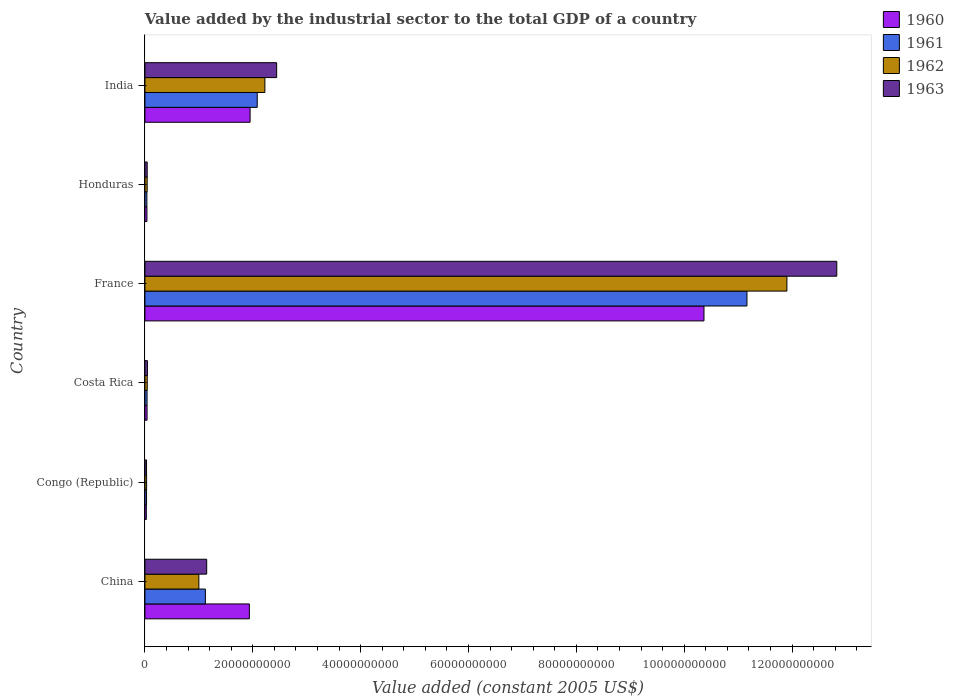How many groups of bars are there?
Make the answer very short. 6. Are the number of bars on each tick of the Y-axis equal?
Your response must be concise. Yes. What is the label of the 1st group of bars from the top?
Ensure brevity in your answer.  India. What is the value added by the industrial sector in 1961 in Honduras?
Ensure brevity in your answer.  3.66e+08. Across all countries, what is the maximum value added by the industrial sector in 1963?
Your answer should be compact. 1.28e+11. Across all countries, what is the minimum value added by the industrial sector in 1961?
Your response must be concise. 2.98e+08. In which country was the value added by the industrial sector in 1961 maximum?
Your response must be concise. France. In which country was the value added by the industrial sector in 1963 minimum?
Provide a succinct answer. Congo (Republic). What is the total value added by the industrial sector in 1962 in the graph?
Ensure brevity in your answer.  1.52e+11. What is the difference between the value added by the industrial sector in 1963 in Congo (Republic) and that in France?
Offer a terse response. -1.28e+11. What is the difference between the value added by the industrial sector in 1960 in Congo (Republic) and the value added by the industrial sector in 1962 in China?
Offer a very short reply. -9.74e+09. What is the average value added by the industrial sector in 1963 per country?
Make the answer very short. 2.76e+1. What is the difference between the value added by the industrial sector in 1960 and value added by the industrial sector in 1961 in Congo (Republic)?
Provide a short and direct response. -3.63e+07. What is the ratio of the value added by the industrial sector in 1960 in Congo (Republic) to that in Honduras?
Your response must be concise. 0.7. Is the value added by the industrial sector in 1962 in China less than that in France?
Offer a terse response. Yes. Is the difference between the value added by the industrial sector in 1960 in Costa Rica and France greater than the difference between the value added by the industrial sector in 1961 in Costa Rica and France?
Give a very brief answer. Yes. What is the difference between the highest and the second highest value added by the industrial sector in 1961?
Provide a succinct answer. 9.08e+1. What is the difference between the highest and the lowest value added by the industrial sector in 1961?
Give a very brief answer. 1.11e+11. In how many countries, is the value added by the industrial sector in 1962 greater than the average value added by the industrial sector in 1962 taken over all countries?
Make the answer very short. 1. Is the sum of the value added by the industrial sector in 1962 in Congo (Republic) and Costa Rica greater than the maximum value added by the industrial sector in 1960 across all countries?
Ensure brevity in your answer.  No. Is it the case that in every country, the sum of the value added by the industrial sector in 1962 and value added by the industrial sector in 1963 is greater than the sum of value added by the industrial sector in 1960 and value added by the industrial sector in 1961?
Offer a terse response. No. What does the 4th bar from the top in China represents?
Offer a very short reply. 1960. Are all the bars in the graph horizontal?
Your answer should be very brief. Yes. What is the difference between two consecutive major ticks on the X-axis?
Your response must be concise. 2.00e+1. Are the values on the major ticks of X-axis written in scientific E-notation?
Keep it short and to the point. No. Does the graph contain grids?
Ensure brevity in your answer.  No. Where does the legend appear in the graph?
Make the answer very short. Top right. What is the title of the graph?
Your answer should be compact. Value added by the industrial sector to the total GDP of a country. What is the label or title of the X-axis?
Offer a very short reply. Value added (constant 2005 US$). What is the Value added (constant 2005 US$) in 1960 in China?
Your answer should be very brief. 1.94e+1. What is the Value added (constant 2005 US$) in 1961 in China?
Keep it short and to the point. 1.12e+1. What is the Value added (constant 2005 US$) in 1962 in China?
Offer a very short reply. 1.00e+1. What is the Value added (constant 2005 US$) in 1963 in China?
Offer a very short reply. 1.15e+1. What is the Value added (constant 2005 US$) of 1960 in Congo (Republic)?
Offer a terse response. 2.61e+08. What is the Value added (constant 2005 US$) in 1961 in Congo (Republic)?
Make the answer very short. 2.98e+08. What is the Value added (constant 2005 US$) of 1962 in Congo (Republic)?
Ensure brevity in your answer.  3.12e+08. What is the Value added (constant 2005 US$) of 1963 in Congo (Republic)?
Give a very brief answer. 3.00e+08. What is the Value added (constant 2005 US$) in 1960 in Costa Rica?
Provide a short and direct response. 3.98e+08. What is the Value added (constant 2005 US$) of 1961 in Costa Rica?
Keep it short and to the point. 3.94e+08. What is the Value added (constant 2005 US$) in 1962 in Costa Rica?
Your answer should be very brief. 4.27e+08. What is the Value added (constant 2005 US$) of 1963 in Costa Rica?
Provide a short and direct response. 4.68e+08. What is the Value added (constant 2005 US$) of 1960 in France?
Your answer should be compact. 1.04e+11. What is the Value added (constant 2005 US$) in 1961 in France?
Provide a short and direct response. 1.12e+11. What is the Value added (constant 2005 US$) of 1962 in France?
Offer a terse response. 1.19e+11. What is the Value added (constant 2005 US$) in 1963 in France?
Offer a very short reply. 1.28e+11. What is the Value added (constant 2005 US$) of 1960 in Honduras?
Ensure brevity in your answer.  3.75e+08. What is the Value added (constant 2005 US$) of 1961 in Honduras?
Offer a very short reply. 3.66e+08. What is the Value added (constant 2005 US$) in 1962 in Honduras?
Your answer should be very brief. 4.16e+08. What is the Value added (constant 2005 US$) of 1963 in Honduras?
Make the answer very short. 4.23e+08. What is the Value added (constant 2005 US$) of 1960 in India?
Offer a very short reply. 1.95e+1. What is the Value added (constant 2005 US$) in 1961 in India?
Make the answer very short. 2.08e+1. What is the Value added (constant 2005 US$) in 1962 in India?
Offer a terse response. 2.22e+1. What is the Value added (constant 2005 US$) in 1963 in India?
Your response must be concise. 2.44e+1. Across all countries, what is the maximum Value added (constant 2005 US$) of 1960?
Your response must be concise. 1.04e+11. Across all countries, what is the maximum Value added (constant 2005 US$) in 1961?
Offer a terse response. 1.12e+11. Across all countries, what is the maximum Value added (constant 2005 US$) of 1962?
Keep it short and to the point. 1.19e+11. Across all countries, what is the maximum Value added (constant 2005 US$) in 1963?
Offer a very short reply. 1.28e+11. Across all countries, what is the minimum Value added (constant 2005 US$) of 1960?
Your response must be concise. 2.61e+08. Across all countries, what is the minimum Value added (constant 2005 US$) of 1961?
Your response must be concise. 2.98e+08. Across all countries, what is the minimum Value added (constant 2005 US$) in 1962?
Provide a short and direct response. 3.12e+08. Across all countries, what is the minimum Value added (constant 2005 US$) of 1963?
Provide a succinct answer. 3.00e+08. What is the total Value added (constant 2005 US$) in 1960 in the graph?
Offer a terse response. 1.44e+11. What is the total Value added (constant 2005 US$) in 1961 in the graph?
Offer a terse response. 1.45e+11. What is the total Value added (constant 2005 US$) of 1962 in the graph?
Provide a short and direct response. 1.52e+11. What is the total Value added (constant 2005 US$) in 1963 in the graph?
Your answer should be very brief. 1.65e+11. What is the difference between the Value added (constant 2005 US$) in 1960 in China and that in Congo (Republic)?
Your answer should be compact. 1.91e+1. What is the difference between the Value added (constant 2005 US$) of 1961 in China and that in Congo (Republic)?
Offer a very short reply. 1.09e+1. What is the difference between the Value added (constant 2005 US$) of 1962 in China and that in Congo (Republic)?
Your answer should be compact. 9.69e+09. What is the difference between the Value added (constant 2005 US$) in 1963 in China and that in Congo (Republic)?
Keep it short and to the point. 1.12e+1. What is the difference between the Value added (constant 2005 US$) in 1960 in China and that in Costa Rica?
Give a very brief answer. 1.90e+1. What is the difference between the Value added (constant 2005 US$) in 1961 in China and that in Costa Rica?
Your response must be concise. 1.08e+1. What is the difference between the Value added (constant 2005 US$) of 1962 in China and that in Costa Rica?
Ensure brevity in your answer.  9.58e+09. What is the difference between the Value added (constant 2005 US$) of 1963 in China and that in Costa Rica?
Give a very brief answer. 1.10e+1. What is the difference between the Value added (constant 2005 US$) in 1960 in China and that in France?
Provide a short and direct response. -8.43e+1. What is the difference between the Value added (constant 2005 US$) in 1961 in China and that in France?
Provide a short and direct response. -1.00e+11. What is the difference between the Value added (constant 2005 US$) in 1962 in China and that in France?
Ensure brevity in your answer.  -1.09e+11. What is the difference between the Value added (constant 2005 US$) in 1963 in China and that in France?
Keep it short and to the point. -1.17e+11. What is the difference between the Value added (constant 2005 US$) of 1960 in China and that in Honduras?
Offer a terse response. 1.90e+1. What is the difference between the Value added (constant 2005 US$) of 1961 in China and that in Honduras?
Your answer should be very brief. 1.08e+1. What is the difference between the Value added (constant 2005 US$) of 1962 in China and that in Honduras?
Provide a succinct answer. 9.59e+09. What is the difference between the Value added (constant 2005 US$) of 1963 in China and that in Honduras?
Offer a terse response. 1.10e+1. What is the difference between the Value added (constant 2005 US$) of 1960 in China and that in India?
Your answer should be very brief. -1.35e+08. What is the difference between the Value added (constant 2005 US$) in 1961 in China and that in India?
Offer a very short reply. -9.61e+09. What is the difference between the Value added (constant 2005 US$) in 1962 in China and that in India?
Offer a terse response. -1.22e+1. What is the difference between the Value added (constant 2005 US$) in 1963 in China and that in India?
Give a very brief answer. -1.30e+1. What is the difference between the Value added (constant 2005 US$) in 1960 in Congo (Republic) and that in Costa Rica?
Ensure brevity in your answer.  -1.36e+08. What is the difference between the Value added (constant 2005 US$) in 1961 in Congo (Republic) and that in Costa Rica?
Give a very brief answer. -9.59e+07. What is the difference between the Value added (constant 2005 US$) of 1962 in Congo (Republic) and that in Costa Rica?
Your answer should be compact. -1.14e+08. What is the difference between the Value added (constant 2005 US$) in 1963 in Congo (Republic) and that in Costa Rica?
Offer a very short reply. -1.68e+08. What is the difference between the Value added (constant 2005 US$) in 1960 in Congo (Republic) and that in France?
Your answer should be very brief. -1.03e+11. What is the difference between the Value added (constant 2005 US$) in 1961 in Congo (Republic) and that in France?
Your answer should be compact. -1.11e+11. What is the difference between the Value added (constant 2005 US$) in 1962 in Congo (Republic) and that in France?
Ensure brevity in your answer.  -1.19e+11. What is the difference between the Value added (constant 2005 US$) of 1963 in Congo (Republic) and that in France?
Provide a succinct answer. -1.28e+11. What is the difference between the Value added (constant 2005 US$) of 1960 in Congo (Republic) and that in Honduras?
Offer a very short reply. -1.14e+08. What is the difference between the Value added (constant 2005 US$) of 1961 in Congo (Republic) and that in Honduras?
Keep it short and to the point. -6.81e+07. What is the difference between the Value added (constant 2005 US$) in 1962 in Congo (Republic) and that in Honduras?
Offer a very short reply. -1.03e+08. What is the difference between the Value added (constant 2005 US$) of 1963 in Congo (Republic) and that in Honduras?
Your response must be concise. -1.23e+08. What is the difference between the Value added (constant 2005 US$) in 1960 in Congo (Republic) and that in India?
Ensure brevity in your answer.  -1.92e+1. What is the difference between the Value added (constant 2005 US$) of 1961 in Congo (Republic) and that in India?
Keep it short and to the point. -2.05e+1. What is the difference between the Value added (constant 2005 US$) in 1962 in Congo (Republic) and that in India?
Provide a short and direct response. -2.19e+1. What is the difference between the Value added (constant 2005 US$) in 1963 in Congo (Republic) and that in India?
Give a very brief answer. -2.41e+1. What is the difference between the Value added (constant 2005 US$) in 1960 in Costa Rica and that in France?
Offer a very short reply. -1.03e+11. What is the difference between the Value added (constant 2005 US$) of 1961 in Costa Rica and that in France?
Ensure brevity in your answer.  -1.11e+11. What is the difference between the Value added (constant 2005 US$) of 1962 in Costa Rica and that in France?
Offer a very short reply. -1.19e+11. What is the difference between the Value added (constant 2005 US$) of 1963 in Costa Rica and that in France?
Offer a very short reply. -1.28e+11. What is the difference between the Value added (constant 2005 US$) of 1960 in Costa Rica and that in Honduras?
Give a very brief answer. 2.26e+07. What is the difference between the Value added (constant 2005 US$) in 1961 in Costa Rica and that in Honduras?
Keep it short and to the point. 2.78e+07. What is the difference between the Value added (constant 2005 US$) of 1962 in Costa Rica and that in Honduras?
Offer a very short reply. 1.10e+07. What is the difference between the Value added (constant 2005 US$) in 1963 in Costa Rica and that in Honduras?
Offer a terse response. 4.49e+07. What is the difference between the Value added (constant 2005 US$) in 1960 in Costa Rica and that in India?
Provide a short and direct response. -1.91e+1. What is the difference between the Value added (constant 2005 US$) of 1961 in Costa Rica and that in India?
Your answer should be very brief. -2.04e+1. What is the difference between the Value added (constant 2005 US$) of 1962 in Costa Rica and that in India?
Keep it short and to the point. -2.18e+1. What is the difference between the Value added (constant 2005 US$) in 1963 in Costa Rica and that in India?
Offer a very short reply. -2.40e+1. What is the difference between the Value added (constant 2005 US$) in 1960 in France and that in Honduras?
Give a very brief answer. 1.03e+11. What is the difference between the Value added (constant 2005 US$) in 1961 in France and that in Honduras?
Your response must be concise. 1.11e+11. What is the difference between the Value added (constant 2005 US$) of 1962 in France and that in Honduras?
Offer a terse response. 1.19e+11. What is the difference between the Value added (constant 2005 US$) in 1963 in France and that in Honduras?
Your answer should be compact. 1.28e+11. What is the difference between the Value added (constant 2005 US$) in 1960 in France and that in India?
Offer a very short reply. 8.42e+1. What is the difference between the Value added (constant 2005 US$) of 1961 in France and that in India?
Give a very brief answer. 9.08e+1. What is the difference between the Value added (constant 2005 US$) in 1962 in France and that in India?
Give a very brief answer. 9.68e+1. What is the difference between the Value added (constant 2005 US$) of 1963 in France and that in India?
Provide a succinct answer. 1.04e+11. What is the difference between the Value added (constant 2005 US$) of 1960 in Honduras and that in India?
Offer a very short reply. -1.91e+1. What is the difference between the Value added (constant 2005 US$) of 1961 in Honduras and that in India?
Make the answer very short. -2.05e+1. What is the difference between the Value added (constant 2005 US$) of 1962 in Honduras and that in India?
Your answer should be very brief. -2.18e+1. What is the difference between the Value added (constant 2005 US$) of 1963 in Honduras and that in India?
Give a very brief answer. -2.40e+1. What is the difference between the Value added (constant 2005 US$) of 1960 in China and the Value added (constant 2005 US$) of 1961 in Congo (Republic)?
Make the answer very short. 1.91e+1. What is the difference between the Value added (constant 2005 US$) of 1960 in China and the Value added (constant 2005 US$) of 1962 in Congo (Republic)?
Provide a short and direct response. 1.91e+1. What is the difference between the Value added (constant 2005 US$) of 1960 in China and the Value added (constant 2005 US$) of 1963 in Congo (Republic)?
Your response must be concise. 1.91e+1. What is the difference between the Value added (constant 2005 US$) in 1961 in China and the Value added (constant 2005 US$) in 1962 in Congo (Republic)?
Provide a succinct answer. 1.09e+1. What is the difference between the Value added (constant 2005 US$) of 1961 in China and the Value added (constant 2005 US$) of 1963 in Congo (Republic)?
Provide a succinct answer. 1.09e+1. What is the difference between the Value added (constant 2005 US$) of 1962 in China and the Value added (constant 2005 US$) of 1963 in Congo (Republic)?
Ensure brevity in your answer.  9.70e+09. What is the difference between the Value added (constant 2005 US$) in 1960 in China and the Value added (constant 2005 US$) in 1961 in Costa Rica?
Offer a very short reply. 1.90e+1. What is the difference between the Value added (constant 2005 US$) in 1960 in China and the Value added (constant 2005 US$) in 1962 in Costa Rica?
Provide a succinct answer. 1.89e+1. What is the difference between the Value added (constant 2005 US$) of 1960 in China and the Value added (constant 2005 US$) of 1963 in Costa Rica?
Offer a terse response. 1.89e+1. What is the difference between the Value added (constant 2005 US$) of 1961 in China and the Value added (constant 2005 US$) of 1962 in Costa Rica?
Offer a terse response. 1.08e+1. What is the difference between the Value added (constant 2005 US$) of 1961 in China and the Value added (constant 2005 US$) of 1963 in Costa Rica?
Offer a terse response. 1.07e+1. What is the difference between the Value added (constant 2005 US$) of 1962 in China and the Value added (constant 2005 US$) of 1963 in Costa Rica?
Your answer should be compact. 9.53e+09. What is the difference between the Value added (constant 2005 US$) of 1960 in China and the Value added (constant 2005 US$) of 1961 in France?
Keep it short and to the point. -9.23e+1. What is the difference between the Value added (constant 2005 US$) in 1960 in China and the Value added (constant 2005 US$) in 1962 in France?
Your response must be concise. -9.97e+1. What is the difference between the Value added (constant 2005 US$) in 1960 in China and the Value added (constant 2005 US$) in 1963 in France?
Keep it short and to the point. -1.09e+11. What is the difference between the Value added (constant 2005 US$) in 1961 in China and the Value added (constant 2005 US$) in 1962 in France?
Offer a very short reply. -1.08e+11. What is the difference between the Value added (constant 2005 US$) in 1961 in China and the Value added (constant 2005 US$) in 1963 in France?
Offer a terse response. -1.17e+11. What is the difference between the Value added (constant 2005 US$) in 1962 in China and the Value added (constant 2005 US$) in 1963 in France?
Ensure brevity in your answer.  -1.18e+11. What is the difference between the Value added (constant 2005 US$) of 1960 in China and the Value added (constant 2005 US$) of 1961 in Honduras?
Make the answer very short. 1.90e+1. What is the difference between the Value added (constant 2005 US$) in 1960 in China and the Value added (constant 2005 US$) in 1962 in Honduras?
Provide a succinct answer. 1.90e+1. What is the difference between the Value added (constant 2005 US$) in 1960 in China and the Value added (constant 2005 US$) in 1963 in Honduras?
Provide a short and direct response. 1.89e+1. What is the difference between the Value added (constant 2005 US$) in 1961 in China and the Value added (constant 2005 US$) in 1962 in Honduras?
Keep it short and to the point. 1.08e+1. What is the difference between the Value added (constant 2005 US$) in 1961 in China and the Value added (constant 2005 US$) in 1963 in Honduras?
Make the answer very short. 1.08e+1. What is the difference between the Value added (constant 2005 US$) in 1962 in China and the Value added (constant 2005 US$) in 1963 in Honduras?
Provide a succinct answer. 9.58e+09. What is the difference between the Value added (constant 2005 US$) in 1960 in China and the Value added (constant 2005 US$) in 1961 in India?
Make the answer very short. -1.46e+09. What is the difference between the Value added (constant 2005 US$) in 1960 in China and the Value added (constant 2005 US$) in 1962 in India?
Provide a short and direct response. -2.88e+09. What is the difference between the Value added (constant 2005 US$) of 1960 in China and the Value added (constant 2005 US$) of 1963 in India?
Make the answer very short. -5.06e+09. What is the difference between the Value added (constant 2005 US$) of 1961 in China and the Value added (constant 2005 US$) of 1962 in India?
Provide a succinct answer. -1.10e+1. What is the difference between the Value added (constant 2005 US$) of 1961 in China and the Value added (constant 2005 US$) of 1963 in India?
Your response must be concise. -1.32e+1. What is the difference between the Value added (constant 2005 US$) in 1962 in China and the Value added (constant 2005 US$) in 1963 in India?
Offer a terse response. -1.44e+1. What is the difference between the Value added (constant 2005 US$) in 1960 in Congo (Republic) and the Value added (constant 2005 US$) in 1961 in Costa Rica?
Your answer should be compact. -1.32e+08. What is the difference between the Value added (constant 2005 US$) in 1960 in Congo (Republic) and the Value added (constant 2005 US$) in 1962 in Costa Rica?
Your answer should be very brief. -1.65e+08. What is the difference between the Value added (constant 2005 US$) of 1960 in Congo (Republic) and the Value added (constant 2005 US$) of 1963 in Costa Rica?
Your response must be concise. -2.07e+08. What is the difference between the Value added (constant 2005 US$) in 1961 in Congo (Republic) and the Value added (constant 2005 US$) in 1962 in Costa Rica?
Give a very brief answer. -1.29e+08. What is the difference between the Value added (constant 2005 US$) in 1961 in Congo (Republic) and the Value added (constant 2005 US$) in 1963 in Costa Rica?
Offer a very short reply. -1.70e+08. What is the difference between the Value added (constant 2005 US$) in 1962 in Congo (Republic) and the Value added (constant 2005 US$) in 1963 in Costa Rica?
Your answer should be very brief. -1.56e+08. What is the difference between the Value added (constant 2005 US$) in 1960 in Congo (Republic) and the Value added (constant 2005 US$) in 1961 in France?
Your answer should be very brief. -1.11e+11. What is the difference between the Value added (constant 2005 US$) in 1960 in Congo (Republic) and the Value added (constant 2005 US$) in 1962 in France?
Give a very brief answer. -1.19e+11. What is the difference between the Value added (constant 2005 US$) in 1960 in Congo (Republic) and the Value added (constant 2005 US$) in 1963 in France?
Your answer should be compact. -1.28e+11. What is the difference between the Value added (constant 2005 US$) in 1961 in Congo (Republic) and the Value added (constant 2005 US$) in 1962 in France?
Your response must be concise. -1.19e+11. What is the difference between the Value added (constant 2005 US$) of 1961 in Congo (Republic) and the Value added (constant 2005 US$) of 1963 in France?
Offer a very short reply. -1.28e+11. What is the difference between the Value added (constant 2005 US$) in 1962 in Congo (Republic) and the Value added (constant 2005 US$) in 1963 in France?
Offer a very short reply. -1.28e+11. What is the difference between the Value added (constant 2005 US$) of 1960 in Congo (Republic) and the Value added (constant 2005 US$) of 1961 in Honduras?
Provide a succinct answer. -1.04e+08. What is the difference between the Value added (constant 2005 US$) of 1960 in Congo (Republic) and the Value added (constant 2005 US$) of 1962 in Honduras?
Keep it short and to the point. -1.54e+08. What is the difference between the Value added (constant 2005 US$) of 1960 in Congo (Republic) and the Value added (constant 2005 US$) of 1963 in Honduras?
Your response must be concise. -1.62e+08. What is the difference between the Value added (constant 2005 US$) of 1961 in Congo (Republic) and the Value added (constant 2005 US$) of 1962 in Honduras?
Your response must be concise. -1.18e+08. What is the difference between the Value added (constant 2005 US$) of 1961 in Congo (Republic) and the Value added (constant 2005 US$) of 1963 in Honduras?
Give a very brief answer. -1.25e+08. What is the difference between the Value added (constant 2005 US$) of 1962 in Congo (Republic) and the Value added (constant 2005 US$) of 1963 in Honduras?
Your answer should be very brief. -1.11e+08. What is the difference between the Value added (constant 2005 US$) of 1960 in Congo (Republic) and the Value added (constant 2005 US$) of 1961 in India?
Keep it short and to the point. -2.06e+1. What is the difference between the Value added (constant 2005 US$) of 1960 in Congo (Republic) and the Value added (constant 2005 US$) of 1962 in India?
Ensure brevity in your answer.  -2.20e+1. What is the difference between the Value added (constant 2005 US$) in 1960 in Congo (Republic) and the Value added (constant 2005 US$) in 1963 in India?
Your response must be concise. -2.42e+1. What is the difference between the Value added (constant 2005 US$) of 1961 in Congo (Republic) and the Value added (constant 2005 US$) of 1962 in India?
Keep it short and to the point. -2.19e+1. What is the difference between the Value added (constant 2005 US$) of 1961 in Congo (Republic) and the Value added (constant 2005 US$) of 1963 in India?
Provide a short and direct response. -2.41e+1. What is the difference between the Value added (constant 2005 US$) of 1962 in Congo (Republic) and the Value added (constant 2005 US$) of 1963 in India?
Ensure brevity in your answer.  -2.41e+1. What is the difference between the Value added (constant 2005 US$) in 1960 in Costa Rica and the Value added (constant 2005 US$) in 1961 in France?
Provide a succinct answer. -1.11e+11. What is the difference between the Value added (constant 2005 US$) of 1960 in Costa Rica and the Value added (constant 2005 US$) of 1962 in France?
Your answer should be very brief. -1.19e+11. What is the difference between the Value added (constant 2005 US$) in 1960 in Costa Rica and the Value added (constant 2005 US$) in 1963 in France?
Provide a succinct answer. -1.28e+11. What is the difference between the Value added (constant 2005 US$) of 1961 in Costa Rica and the Value added (constant 2005 US$) of 1962 in France?
Your answer should be compact. -1.19e+11. What is the difference between the Value added (constant 2005 US$) of 1961 in Costa Rica and the Value added (constant 2005 US$) of 1963 in France?
Offer a terse response. -1.28e+11. What is the difference between the Value added (constant 2005 US$) of 1962 in Costa Rica and the Value added (constant 2005 US$) of 1963 in France?
Ensure brevity in your answer.  -1.28e+11. What is the difference between the Value added (constant 2005 US$) in 1960 in Costa Rica and the Value added (constant 2005 US$) in 1961 in Honduras?
Provide a succinct answer. 3.20e+07. What is the difference between the Value added (constant 2005 US$) of 1960 in Costa Rica and the Value added (constant 2005 US$) of 1962 in Honduras?
Your answer should be very brief. -1.81e+07. What is the difference between the Value added (constant 2005 US$) in 1960 in Costa Rica and the Value added (constant 2005 US$) in 1963 in Honduras?
Offer a terse response. -2.52e+07. What is the difference between the Value added (constant 2005 US$) of 1961 in Costa Rica and the Value added (constant 2005 US$) of 1962 in Honduras?
Your answer should be compact. -2.22e+07. What is the difference between the Value added (constant 2005 US$) in 1961 in Costa Rica and the Value added (constant 2005 US$) in 1963 in Honduras?
Your response must be concise. -2.94e+07. What is the difference between the Value added (constant 2005 US$) in 1962 in Costa Rica and the Value added (constant 2005 US$) in 1963 in Honduras?
Your answer should be compact. 3.81e+06. What is the difference between the Value added (constant 2005 US$) in 1960 in Costa Rica and the Value added (constant 2005 US$) in 1961 in India?
Your answer should be compact. -2.04e+1. What is the difference between the Value added (constant 2005 US$) of 1960 in Costa Rica and the Value added (constant 2005 US$) of 1962 in India?
Make the answer very short. -2.18e+1. What is the difference between the Value added (constant 2005 US$) in 1960 in Costa Rica and the Value added (constant 2005 US$) in 1963 in India?
Provide a short and direct response. -2.40e+1. What is the difference between the Value added (constant 2005 US$) of 1961 in Costa Rica and the Value added (constant 2005 US$) of 1962 in India?
Provide a short and direct response. -2.19e+1. What is the difference between the Value added (constant 2005 US$) of 1961 in Costa Rica and the Value added (constant 2005 US$) of 1963 in India?
Your response must be concise. -2.40e+1. What is the difference between the Value added (constant 2005 US$) of 1962 in Costa Rica and the Value added (constant 2005 US$) of 1963 in India?
Offer a terse response. -2.40e+1. What is the difference between the Value added (constant 2005 US$) of 1960 in France and the Value added (constant 2005 US$) of 1961 in Honduras?
Your answer should be very brief. 1.03e+11. What is the difference between the Value added (constant 2005 US$) of 1960 in France and the Value added (constant 2005 US$) of 1962 in Honduras?
Provide a succinct answer. 1.03e+11. What is the difference between the Value added (constant 2005 US$) in 1960 in France and the Value added (constant 2005 US$) in 1963 in Honduras?
Provide a succinct answer. 1.03e+11. What is the difference between the Value added (constant 2005 US$) in 1961 in France and the Value added (constant 2005 US$) in 1962 in Honduras?
Your response must be concise. 1.11e+11. What is the difference between the Value added (constant 2005 US$) of 1961 in France and the Value added (constant 2005 US$) of 1963 in Honduras?
Ensure brevity in your answer.  1.11e+11. What is the difference between the Value added (constant 2005 US$) of 1962 in France and the Value added (constant 2005 US$) of 1963 in Honduras?
Offer a terse response. 1.19e+11. What is the difference between the Value added (constant 2005 US$) in 1960 in France and the Value added (constant 2005 US$) in 1961 in India?
Provide a succinct answer. 8.28e+1. What is the difference between the Value added (constant 2005 US$) of 1960 in France and the Value added (constant 2005 US$) of 1962 in India?
Provide a succinct answer. 8.14e+1. What is the difference between the Value added (constant 2005 US$) in 1960 in France and the Value added (constant 2005 US$) in 1963 in India?
Keep it short and to the point. 7.92e+1. What is the difference between the Value added (constant 2005 US$) in 1961 in France and the Value added (constant 2005 US$) in 1962 in India?
Your answer should be compact. 8.94e+1. What is the difference between the Value added (constant 2005 US$) in 1961 in France and the Value added (constant 2005 US$) in 1963 in India?
Make the answer very short. 8.72e+1. What is the difference between the Value added (constant 2005 US$) in 1962 in France and the Value added (constant 2005 US$) in 1963 in India?
Ensure brevity in your answer.  9.46e+1. What is the difference between the Value added (constant 2005 US$) of 1960 in Honduras and the Value added (constant 2005 US$) of 1961 in India?
Ensure brevity in your answer.  -2.05e+1. What is the difference between the Value added (constant 2005 US$) of 1960 in Honduras and the Value added (constant 2005 US$) of 1962 in India?
Offer a terse response. -2.19e+1. What is the difference between the Value added (constant 2005 US$) of 1960 in Honduras and the Value added (constant 2005 US$) of 1963 in India?
Your answer should be compact. -2.41e+1. What is the difference between the Value added (constant 2005 US$) in 1961 in Honduras and the Value added (constant 2005 US$) in 1962 in India?
Offer a very short reply. -2.19e+1. What is the difference between the Value added (constant 2005 US$) in 1961 in Honduras and the Value added (constant 2005 US$) in 1963 in India?
Offer a very short reply. -2.41e+1. What is the difference between the Value added (constant 2005 US$) in 1962 in Honduras and the Value added (constant 2005 US$) in 1963 in India?
Give a very brief answer. -2.40e+1. What is the average Value added (constant 2005 US$) in 1960 per country?
Offer a very short reply. 2.39e+1. What is the average Value added (constant 2005 US$) of 1961 per country?
Make the answer very short. 2.41e+1. What is the average Value added (constant 2005 US$) of 1962 per country?
Offer a very short reply. 2.54e+1. What is the average Value added (constant 2005 US$) in 1963 per country?
Your response must be concise. 2.76e+1. What is the difference between the Value added (constant 2005 US$) in 1960 and Value added (constant 2005 US$) in 1961 in China?
Your answer should be very brief. 8.15e+09. What is the difference between the Value added (constant 2005 US$) of 1960 and Value added (constant 2005 US$) of 1962 in China?
Provide a succinct answer. 9.36e+09. What is the difference between the Value added (constant 2005 US$) in 1960 and Value added (constant 2005 US$) in 1963 in China?
Offer a terse response. 7.91e+09. What is the difference between the Value added (constant 2005 US$) in 1961 and Value added (constant 2005 US$) in 1962 in China?
Offer a terse response. 1.21e+09. What is the difference between the Value added (constant 2005 US$) in 1961 and Value added (constant 2005 US$) in 1963 in China?
Provide a short and direct response. -2.39e+08. What is the difference between the Value added (constant 2005 US$) of 1962 and Value added (constant 2005 US$) of 1963 in China?
Make the answer very short. -1.45e+09. What is the difference between the Value added (constant 2005 US$) of 1960 and Value added (constant 2005 US$) of 1961 in Congo (Republic)?
Ensure brevity in your answer.  -3.63e+07. What is the difference between the Value added (constant 2005 US$) in 1960 and Value added (constant 2005 US$) in 1962 in Congo (Republic)?
Ensure brevity in your answer.  -5.10e+07. What is the difference between the Value added (constant 2005 US$) of 1960 and Value added (constant 2005 US$) of 1963 in Congo (Republic)?
Provide a succinct answer. -3.84e+07. What is the difference between the Value added (constant 2005 US$) in 1961 and Value added (constant 2005 US$) in 1962 in Congo (Republic)?
Keep it short and to the point. -1.47e+07. What is the difference between the Value added (constant 2005 US$) of 1961 and Value added (constant 2005 US$) of 1963 in Congo (Republic)?
Ensure brevity in your answer.  -2.10e+06. What is the difference between the Value added (constant 2005 US$) of 1962 and Value added (constant 2005 US$) of 1963 in Congo (Republic)?
Provide a succinct answer. 1.26e+07. What is the difference between the Value added (constant 2005 US$) of 1960 and Value added (constant 2005 US$) of 1961 in Costa Rica?
Offer a very short reply. 4.19e+06. What is the difference between the Value added (constant 2005 US$) in 1960 and Value added (constant 2005 US$) in 1962 in Costa Rica?
Your answer should be compact. -2.91e+07. What is the difference between the Value added (constant 2005 US$) in 1960 and Value added (constant 2005 US$) in 1963 in Costa Rica?
Offer a terse response. -7.01e+07. What is the difference between the Value added (constant 2005 US$) of 1961 and Value added (constant 2005 US$) of 1962 in Costa Rica?
Your answer should be very brief. -3.32e+07. What is the difference between the Value added (constant 2005 US$) of 1961 and Value added (constant 2005 US$) of 1963 in Costa Rica?
Your response must be concise. -7.43e+07. What is the difference between the Value added (constant 2005 US$) of 1962 and Value added (constant 2005 US$) of 1963 in Costa Rica?
Offer a very short reply. -4.11e+07. What is the difference between the Value added (constant 2005 US$) in 1960 and Value added (constant 2005 US$) in 1961 in France?
Your answer should be very brief. -7.97e+09. What is the difference between the Value added (constant 2005 US$) in 1960 and Value added (constant 2005 US$) in 1962 in France?
Your answer should be compact. -1.54e+1. What is the difference between the Value added (constant 2005 US$) of 1960 and Value added (constant 2005 US$) of 1963 in France?
Provide a short and direct response. -2.46e+1. What is the difference between the Value added (constant 2005 US$) of 1961 and Value added (constant 2005 US$) of 1962 in France?
Make the answer very short. -7.41e+09. What is the difference between the Value added (constant 2005 US$) in 1961 and Value added (constant 2005 US$) in 1963 in France?
Your answer should be very brief. -1.67e+1. What is the difference between the Value added (constant 2005 US$) of 1962 and Value added (constant 2005 US$) of 1963 in France?
Offer a very short reply. -9.25e+09. What is the difference between the Value added (constant 2005 US$) in 1960 and Value added (constant 2005 US$) in 1961 in Honduras?
Make the answer very short. 9.37e+06. What is the difference between the Value added (constant 2005 US$) of 1960 and Value added (constant 2005 US$) of 1962 in Honduras?
Provide a short and direct response. -4.07e+07. What is the difference between the Value added (constant 2005 US$) in 1960 and Value added (constant 2005 US$) in 1963 in Honduras?
Keep it short and to the point. -4.79e+07. What is the difference between the Value added (constant 2005 US$) in 1961 and Value added (constant 2005 US$) in 1962 in Honduras?
Ensure brevity in your answer.  -5.00e+07. What is the difference between the Value added (constant 2005 US$) of 1961 and Value added (constant 2005 US$) of 1963 in Honduras?
Ensure brevity in your answer.  -5.72e+07. What is the difference between the Value added (constant 2005 US$) of 1962 and Value added (constant 2005 US$) of 1963 in Honduras?
Give a very brief answer. -7.19e+06. What is the difference between the Value added (constant 2005 US$) of 1960 and Value added (constant 2005 US$) of 1961 in India?
Ensure brevity in your answer.  -1.32e+09. What is the difference between the Value added (constant 2005 US$) in 1960 and Value added (constant 2005 US$) in 1962 in India?
Provide a succinct answer. -2.74e+09. What is the difference between the Value added (constant 2005 US$) in 1960 and Value added (constant 2005 US$) in 1963 in India?
Give a very brief answer. -4.92e+09. What is the difference between the Value added (constant 2005 US$) in 1961 and Value added (constant 2005 US$) in 1962 in India?
Your answer should be compact. -1.42e+09. What is the difference between the Value added (constant 2005 US$) in 1961 and Value added (constant 2005 US$) in 1963 in India?
Your answer should be compact. -3.60e+09. What is the difference between the Value added (constant 2005 US$) of 1962 and Value added (constant 2005 US$) of 1963 in India?
Make the answer very short. -2.18e+09. What is the ratio of the Value added (constant 2005 US$) in 1960 in China to that in Congo (Republic)?
Give a very brief answer. 74.09. What is the ratio of the Value added (constant 2005 US$) in 1961 in China to that in Congo (Republic)?
Provide a succinct answer. 37.67. What is the ratio of the Value added (constant 2005 US$) in 1962 in China to that in Congo (Republic)?
Provide a short and direct response. 32.02. What is the ratio of the Value added (constant 2005 US$) of 1963 in China to that in Congo (Republic)?
Your answer should be compact. 38.21. What is the ratio of the Value added (constant 2005 US$) in 1960 in China to that in Costa Rica?
Your answer should be very brief. 48.69. What is the ratio of the Value added (constant 2005 US$) of 1961 in China to that in Costa Rica?
Make the answer very short. 28.49. What is the ratio of the Value added (constant 2005 US$) of 1962 in China to that in Costa Rica?
Provide a succinct answer. 23.43. What is the ratio of the Value added (constant 2005 US$) in 1963 in China to that in Costa Rica?
Your answer should be very brief. 24.48. What is the ratio of the Value added (constant 2005 US$) in 1960 in China to that in France?
Give a very brief answer. 0.19. What is the ratio of the Value added (constant 2005 US$) of 1961 in China to that in France?
Offer a terse response. 0.1. What is the ratio of the Value added (constant 2005 US$) in 1962 in China to that in France?
Make the answer very short. 0.08. What is the ratio of the Value added (constant 2005 US$) in 1963 in China to that in France?
Keep it short and to the point. 0.09. What is the ratio of the Value added (constant 2005 US$) of 1960 in China to that in Honduras?
Ensure brevity in your answer.  51.62. What is the ratio of the Value added (constant 2005 US$) in 1961 in China to that in Honduras?
Your answer should be very brief. 30.65. What is the ratio of the Value added (constant 2005 US$) of 1962 in China to that in Honduras?
Your answer should be very brief. 24.05. What is the ratio of the Value added (constant 2005 US$) in 1963 in China to that in Honduras?
Provide a succinct answer. 27.07. What is the ratio of the Value added (constant 2005 US$) in 1960 in China to that in India?
Offer a terse response. 0.99. What is the ratio of the Value added (constant 2005 US$) of 1961 in China to that in India?
Your answer should be compact. 0.54. What is the ratio of the Value added (constant 2005 US$) in 1962 in China to that in India?
Keep it short and to the point. 0.45. What is the ratio of the Value added (constant 2005 US$) in 1963 in China to that in India?
Your answer should be very brief. 0.47. What is the ratio of the Value added (constant 2005 US$) of 1960 in Congo (Republic) to that in Costa Rica?
Your answer should be very brief. 0.66. What is the ratio of the Value added (constant 2005 US$) in 1961 in Congo (Republic) to that in Costa Rica?
Offer a terse response. 0.76. What is the ratio of the Value added (constant 2005 US$) of 1962 in Congo (Republic) to that in Costa Rica?
Offer a very short reply. 0.73. What is the ratio of the Value added (constant 2005 US$) in 1963 in Congo (Republic) to that in Costa Rica?
Your answer should be compact. 0.64. What is the ratio of the Value added (constant 2005 US$) in 1960 in Congo (Republic) to that in France?
Offer a terse response. 0. What is the ratio of the Value added (constant 2005 US$) of 1961 in Congo (Republic) to that in France?
Offer a very short reply. 0. What is the ratio of the Value added (constant 2005 US$) of 1962 in Congo (Republic) to that in France?
Provide a succinct answer. 0. What is the ratio of the Value added (constant 2005 US$) in 1963 in Congo (Republic) to that in France?
Ensure brevity in your answer.  0. What is the ratio of the Value added (constant 2005 US$) in 1960 in Congo (Republic) to that in Honduras?
Your response must be concise. 0.7. What is the ratio of the Value added (constant 2005 US$) in 1961 in Congo (Republic) to that in Honduras?
Provide a succinct answer. 0.81. What is the ratio of the Value added (constant 2005 US$) in 1962 in Congo (Republic) to that in Honduras?
Give a very brief answer. 0.75. What is the ratio of the Value added (constant 2005 US$) of 1963 in Congo (Republic) to that in Honduras?
Provide a succinct answer. 0.71. What is the ratio of the Value added (constant 2005 US$) of 1960 in Congo (Republic) to that in India?
Your response must be concise. 0.01. What is the ratio of the Value added (constant 2005 US$) in 1961 in Congo (Republic) to that in India?
Offer a very short reply. 0.01. What is the ratio of the Value added (constant 2005 US$) of 1962 in Congo (Republic) to that in India?
Give a very brief answer. 0.01. What is the ratio of the Value added (constant 2005 US$) in 1963 in Congo (Republic) to that in India?
Ensure brevity in your answer.  0.01. What is the ratio of the Value added (constant 2005 US$) in 1960 in Costa Rica to that in France?
Make the answer very short. 0. What is the ratio of the Value added (constant 2005 US$) of 1961 in Costa Rica to that in France?
Provide a succinct answer. 0. What is the ratio of the Value added (constant 2005 US$) in 1962 in Costa Rica to that in France?
Your response must be concise. 0. What is the ratio of the Value added (constant 2005 US$) in 1963 in Costa Rica to that in France?
Give a very brief answer. 0. What is the ratio of the Value added (constant 2005 US$) of 1960 in Costa Rica to that in Honduras?
Make the answer very short. 1.06. What is the ratio of the Value added (constant 2005 US$) in 1961 in Costa Rica to that in Honduras?
Provide a succinct answer. 1.08. What is the ratio of the Value added (constant 2005 US$) in 1962 in Costa Rica to that in Honduras?
Keep it short and to the point. 1.03. What is the ratio of the Value added (constant 2005 US$) in 1963 in Costa Rica to that in Honduras?
Provide a succinct answer. 1.11. What is the ratio of the Value added (constant 2005 US$) in 1960 in Costa Rica to that in India?
Your response must be concise. 0.02. What is the ratio of the Value added (constant 2005 US$) in 1961 in Costa Rica to that in India?
Ensure brevity in your answer.  0.02. What is the ratio of the Value added (constant 2005 US$) in 1962 in Costa Rica to that in India?
Your answer should be very brief. 0.02. What is the ratio of the Value added (constant 2005 US$) in 1963 in Costa Rica to that in India?
Offer a very short reply. 0.02. What is the ratio of the Value added (constant 2005 US$) of 1960 in France to that in Honduras?
Keep it short and to the point. 276.31. What is the ratio of the Value added (constant 2005 US$) of 1961 in France to that in Honduras?
Offer a terse response. 305.16. What is the ratio of the Value added (constant 2005 US$) of 1962 in France to that in Honduras?
Keep it short and to the point. 286.26. What is the ratio of the Value added (constant 2005 US$) of 1963 in France to that in Honduras?
Make the answer very short. 303.25. What is the ratio of the Value added (constant 2005 US$) in 1960 in France to that in India?
Your answer should be very brief. 5.32. What is the ratio of the Value added (constant 2005 US$) in 1961 in France to that in India?
Your answer should be compact. 5.36. What is the ratio of the Value added (constant 2005 US$) in 1962 in France to that in India?
Give a very brief answer. 5.35. What is the ratio of the Value added (constant 2005 US$) of 1963 in France to that in India?
Your answer should be very brief. 5.25. What is the ratio of the Value added (constant 2005 US$) in 1960 in Honduras to that in India?
Your response must be concise. 0.02. What is the ratio of the Value added (constant 2005 US$) in 1961 in Honduras to that in India?
Your response must be concise. 0.02. What is the ratio of the Value added (constant 2005 US$) in 1962 in Honduras to that in India?
Ensure brevity in your answer.  0.02. What is the ratio of the Value added (constant 2005 US$) in 1963 in Honduras to that in India?
Keep it short and to the point. 0.02. What is the difference between the highest and the second highest Value added (constant 2005 US$) of 1960?
Give a very brief answer. 8.42e+1. What is the difference between the highest and the second highest Value added (constant 2005 US$) of 1961?
Offer a very short reply. 9.08e+1. What is the difference between the highest and the second highest Value added (constant 2005 US$) of 1962?
Provide a short and direct response. 9.68e+1. What is the difference between the highest and the second highest Value added (constant 2005 US$) of 1963?
Provide a short and direct response. 1.04e+11. What is the difference between the highest and the lowest Value added (constant 2005 US$) of 1960?
Ensure brevity in your answer.  1.03e+11. What is the difference between the highest and the lowest Value added (constant 2005 US$) of 1961?
Provide a short and direct response. 1.11e+11. What is the difference between the highest and the lowest Value added (constant 2005 US$) in 1962?
Your answer should be very brief. 1.19e+11. What is the difference between the highest and the lowest Value added (constant 2005 US$) of 1963?
Your answer should be very brief. 1.28e+11. 